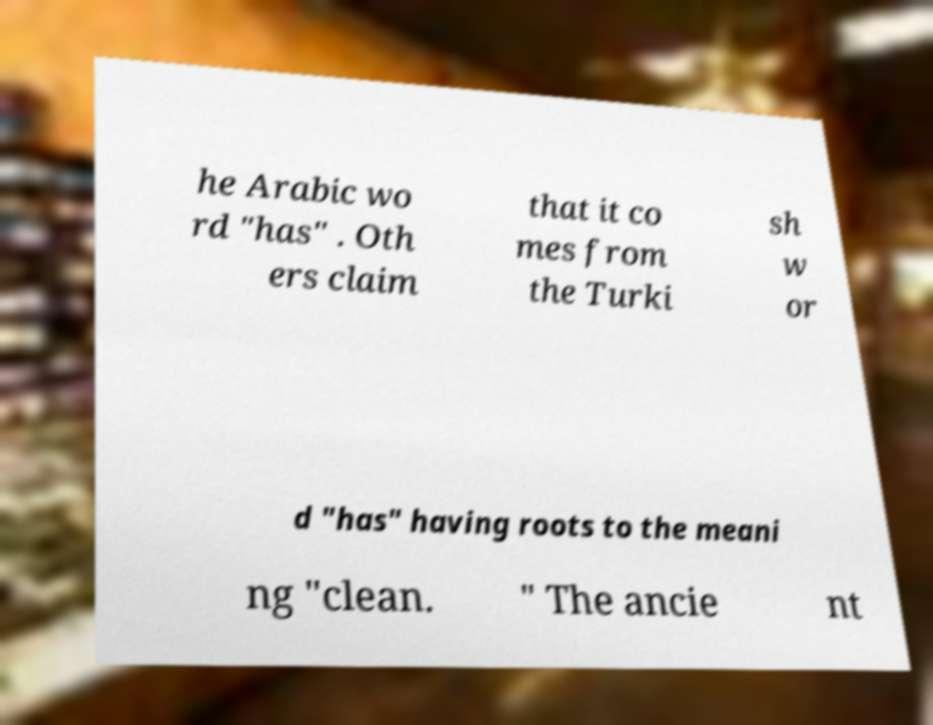Could you assist in decoding the text presented in this image and type it out clearly? he Arabic wo rd "has" . Oth ers claim that it co mes from the Turki sh w or d "has" having roots to the meani ng "clean. " The ancie nt 